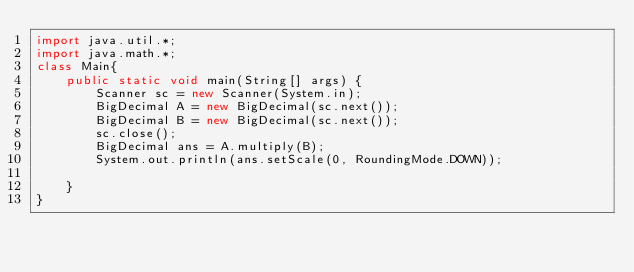Convert code to text. <code><loc_0><loc_0><loc_500><loc_500><_Java_>import java.util.*;
import java.math.*;
class Main{
	public static void main(String[] args) {
		Scanner sc = new Scanner(System.in);
		BigDecimal A = new BigDecimal(sc.next());
		BigDecimal B = new BigDecimal(sc.next());
		sc.close();
		BigDecimal ans = A.multiply(B);
		System.out.println(ans.setScale(0, RoundingMode.DOWN));

	}
}
</code> 